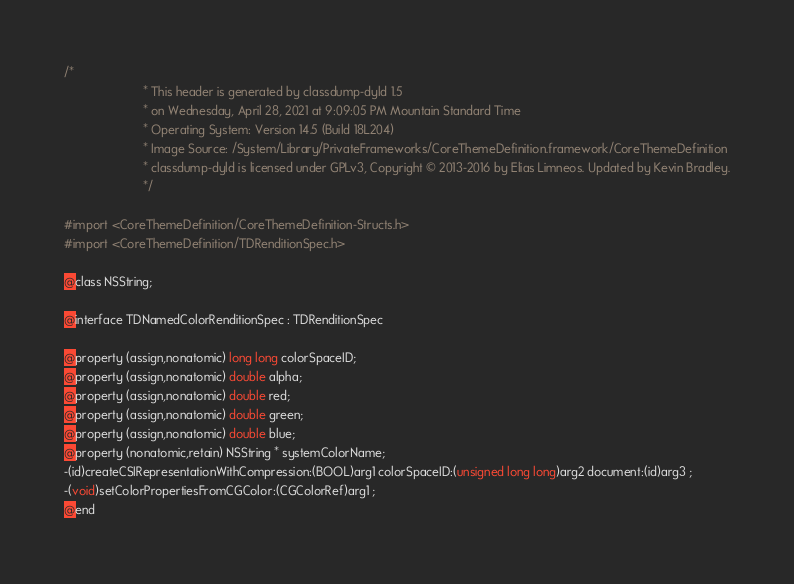Convert code to text. <code><loc_0><loc_0><loc_500><loc_500><_C_>/*
                       * This header is generated by classdump-dyld 1.5
                       * on Wednesday, April 28, 2021 at 9:09:05 PM Mountain Standard Time
                       * Operating System: Version 14.5 (Build 18L204)
                       * Image Source: /System/Library/PrivateFrameworks/CoreThemeDefinition.framework/CoreThemeDefinition
                       * classdump-dyld is licensed under GPLv3, Copyright © 2013-2016 by Elias Limneos. Updated by Kevin Bradley.
                       */

#import <CoreThemeDefinition/CoreThemeDefinition-Structs.h>
#import <CoreThemeDefinition/TDRenditionSpec.h>

@class NSString;

@interface TDNamedColorRenditionSpec : TDRenditionSpec

@property (assign,nonatomic) long long colorSpaceID; 
@property (assign,nonatomic) double alpha; 
@property (assign,nonatomic) double red; 
@property (assign,nonatomic) double green; 
@property (assign,nonatomic) double blue; 
@property (nonatomic,retain) NSString * systemColorName; 
-(id)createCSIRepresentationWithCompression:(BOOL)arg1 colorSpaceID:(unsigned long long)arg2 document:(id)arg3 ;
-(void)setColorPropertiesFromCGColor:(CGColorRef)arg1 ;
@end

</code> 